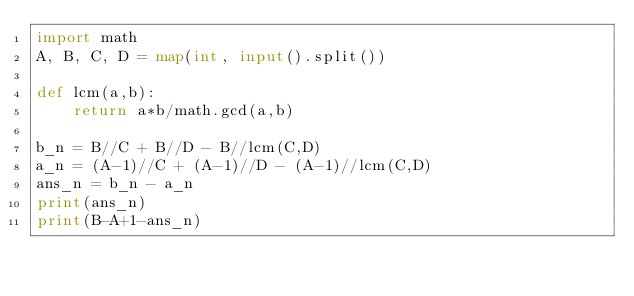<code> <loc_0><loc_0><loc_500><loc_500><_Python_>import math
A, B, C, D = map(int, input().split())

def lcm(a,b):
    return a*b/math.gcd(a,b)

b_n = B//C + B//D - B//lcm(C,D)
a_n = (A-1)//C + (A-1)//D - (A-1)//lcm(C,D)
ans_n = b_n - a_n
print(ans_n)
print(B-A+1-ans_n)</code> 